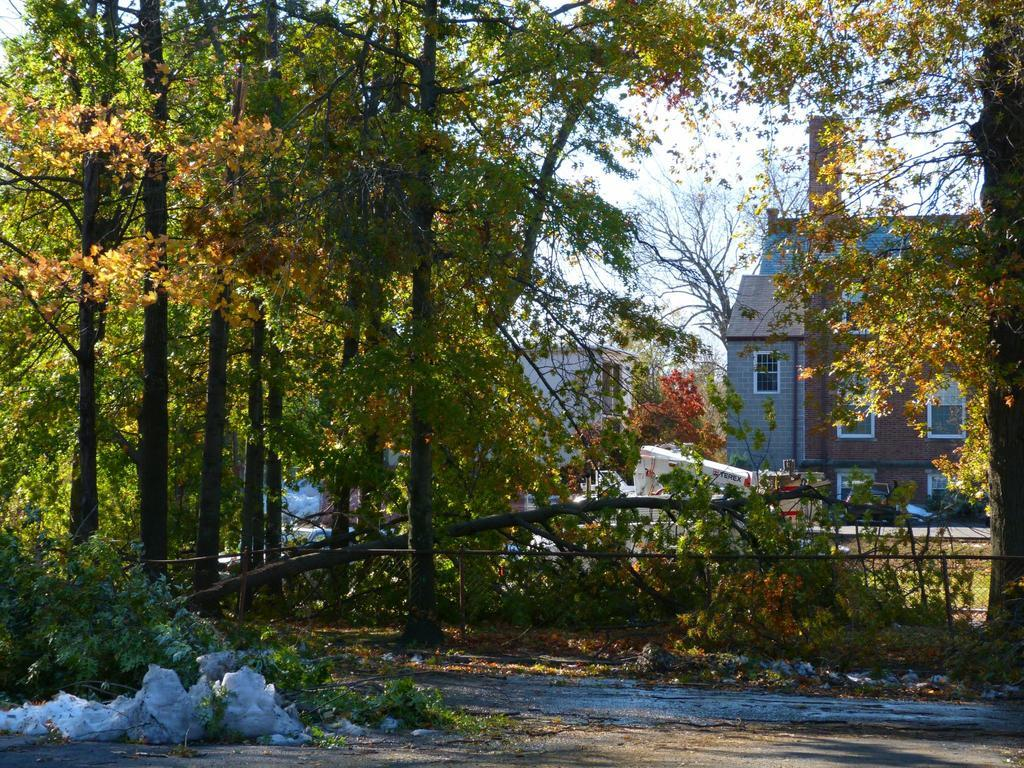What type of natural elements are present in the image? There are trees and plants in the image. What type of man-made structures can be seen in the image? There are houses in the image. What is the color of the sky in the image? The sky is blue in the image. How does the iron help to quiet the noise in the image? There is no iron present in the image, and therefore it cannot help to quiet any noise. 